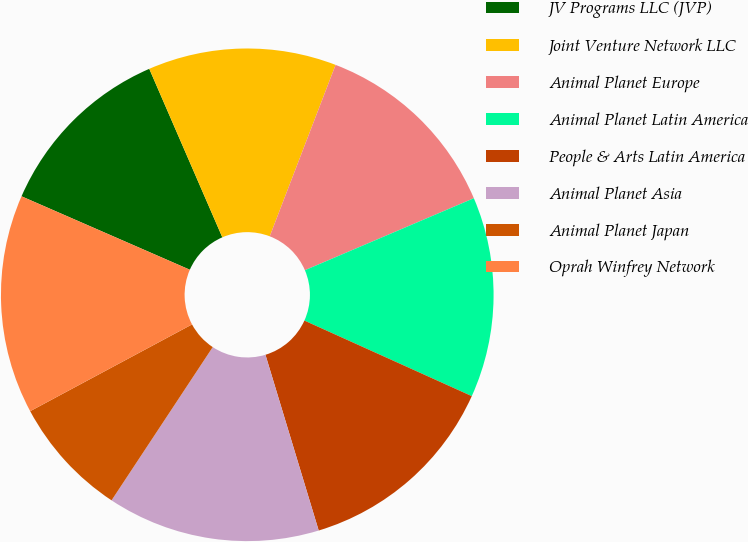Convert chart. <chart><loc_0><loc_0><loc_500><loc_500><pie_chart><fcel>JV Programs LLC (JVP)<fcel>Joint Venture Network LLC<fcel>Animal Planet Europe<fcel>Animal Planet Latin America<fcel>People & Arts Latin America<fcel>Animal Planet Asia<fcel>Animal Planet Japan<fcel>Oprah Winfrey Network<nl><fcel>11.94%<fcel>12.35%<fcel>12.75%<fcel>13.16%<fcel>13.57%<fcel>13.97%<fcel>7.88%<fcel>14.38%<nl></chart> 